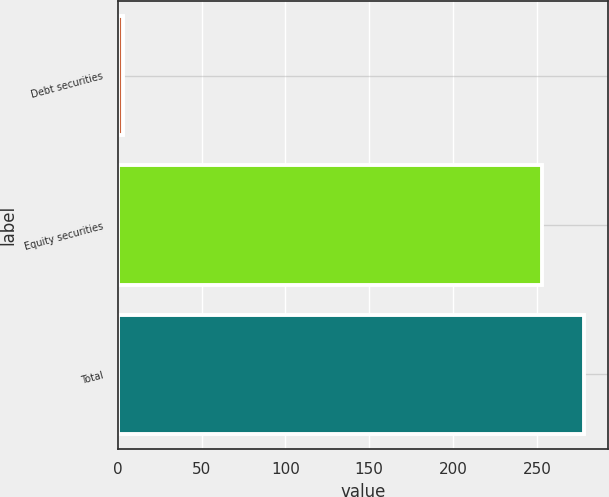<chart> <loc_0><loc_0><loc_500><loc_500><bar_chart><fcel>Debt securities<fcel>Equity securities<fcel>Total<nl><fcel>3<fcel>253<fcel>278.3<nl></chart> 